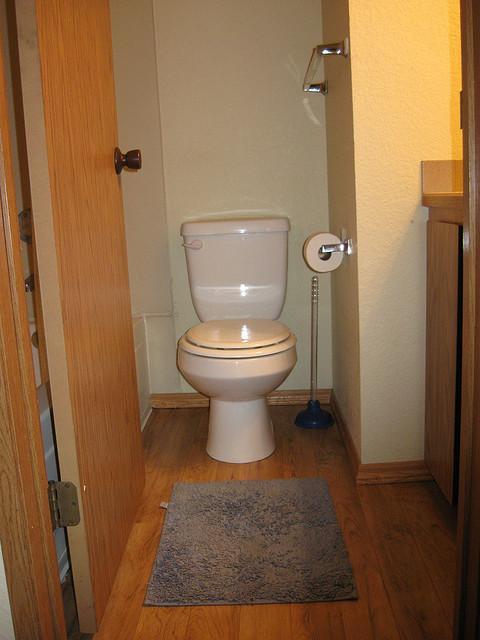How many towels are in the bathroom?
Give a very brief answer. 0. 